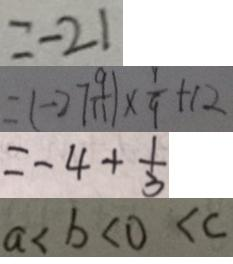<formula> <loc_0><loc_0><loc_500><loc_500>= - 2 1 
 = ( - 2 7 \frac { 9 } { 1 1 } ) \times \frac { 1 } { 9 } + 1 2 
 = - 4 + \frac { 1 } { 3 } 
 a < b < 0 < c</formula> 